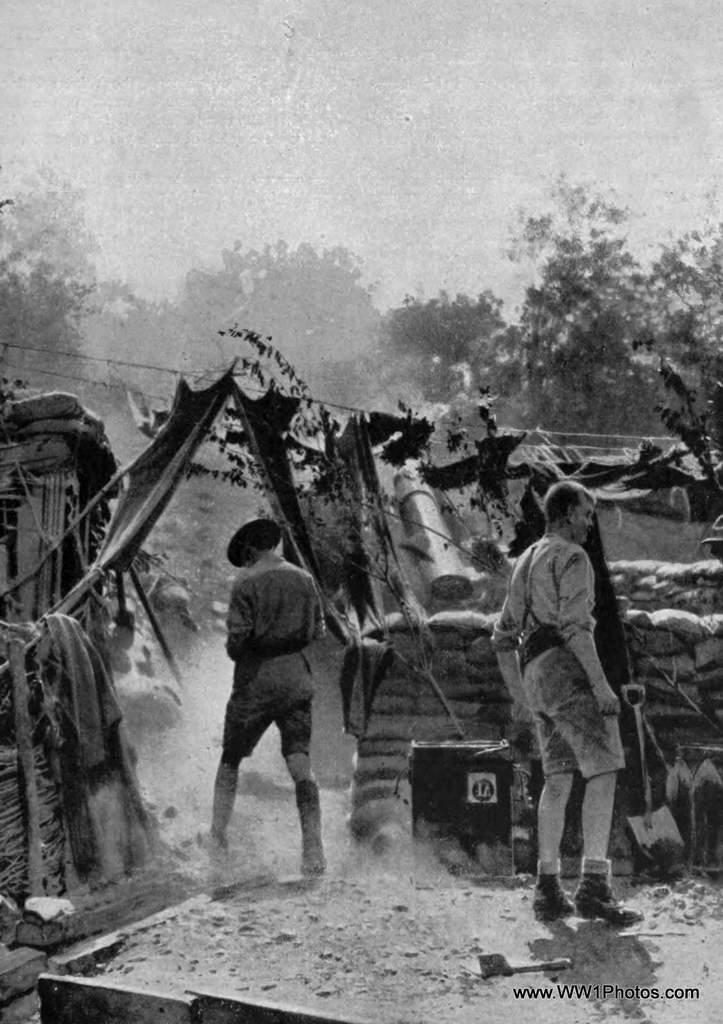What is the color scheme of the image? The image is black and white. What can be seen on the ground in the image? There are men standing on the ground. What tool is present in the image? A shovel is present in the image. How are the sacs arranged in the image? The sacs are arranged in rows. What is hung on a rope in the image? Cloth is hanged on a rope. What type of vegetation is visible in the image? There are trees in the image. What part of the natural environment is visible in the image? The sky is visible in the image. How does the cloth work to generate electricity in the image? The cloth does not work to generate electricity in the image; it is simply hung on a rope. 